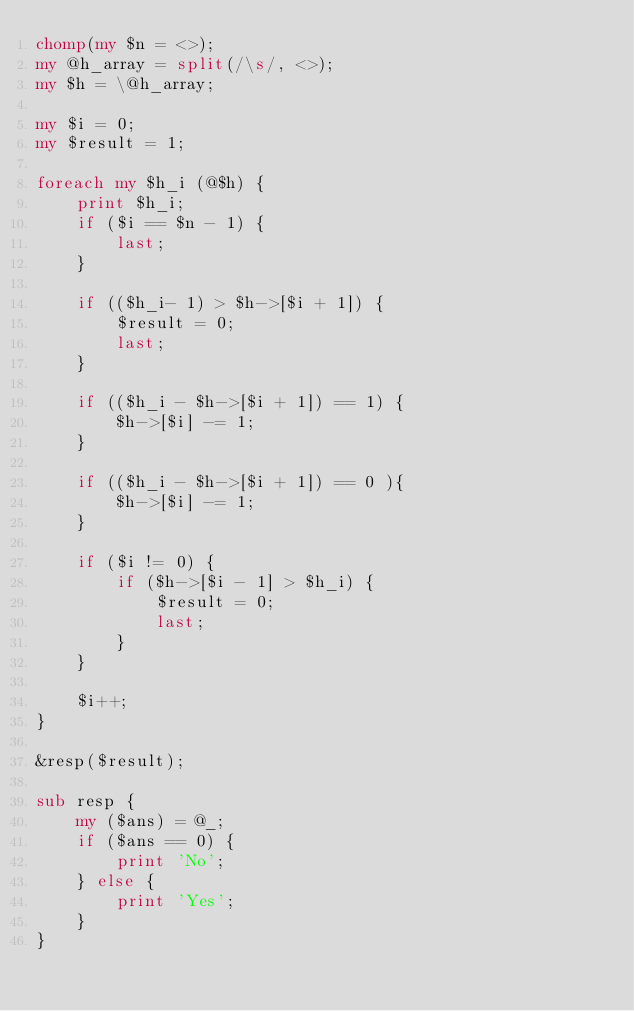<code> <loc_0><loc_0><loc_500><loc_500><_Perl_>chomp(my $n = <>);
my @h_array = split(/\s/, <>);
my $h = \@h_array;

my $i = 0;
my $result = 1;

foreach my $h_i (@$h) {
    print $h_i;
    if ($i == $n - 1) {
        last;
    }

    if (($h_i- 1) > $h->[$i + 1]) {
        $result = 0;
        last;
    }

    if (($h_i - $h->[$i + 1]) == 1) {
        $h->[$i] -= 1;
    }

    if (($h_i - $h->[$i + 1]) == 0 ){
        $h->[$i] -= 1;
    }

    if ($i != 0) {
        if ($h->[$i - 1] > $h_i) {
            $result = 0;
            last;
        }
    }

    $i++;
}

&resp($result);

sub resp {
    my ($ans) = @_;
    if ($ans == 0) {
        print 'No';
    } else {
        print 'Yes';
    }
}
</code> 